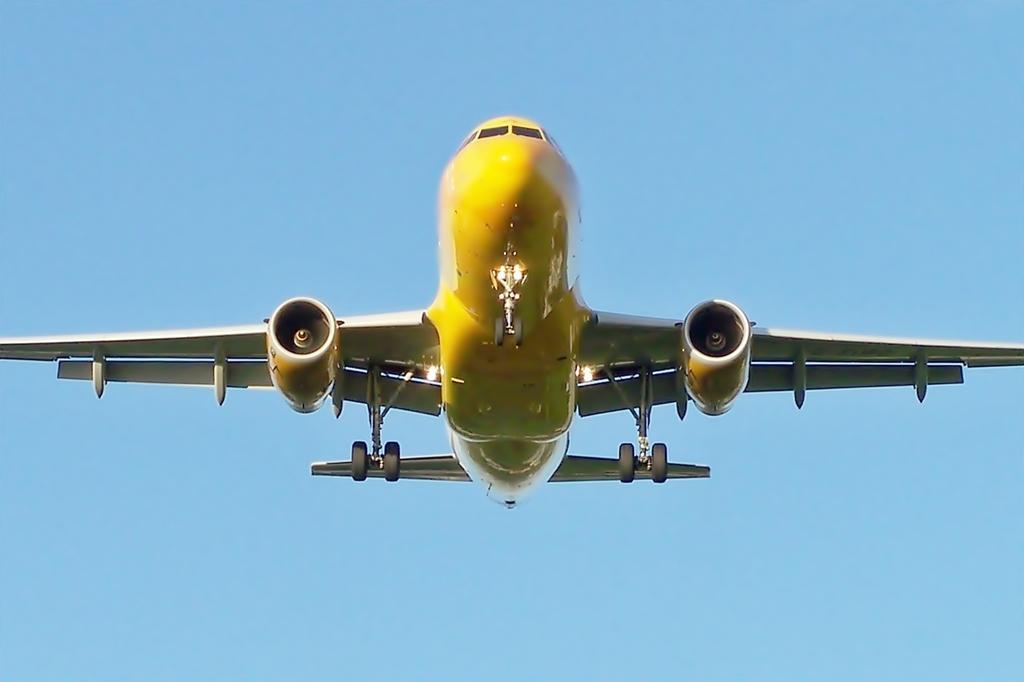Describe this image in one or two sentences. In this image we can see the aircraft in the sky. 